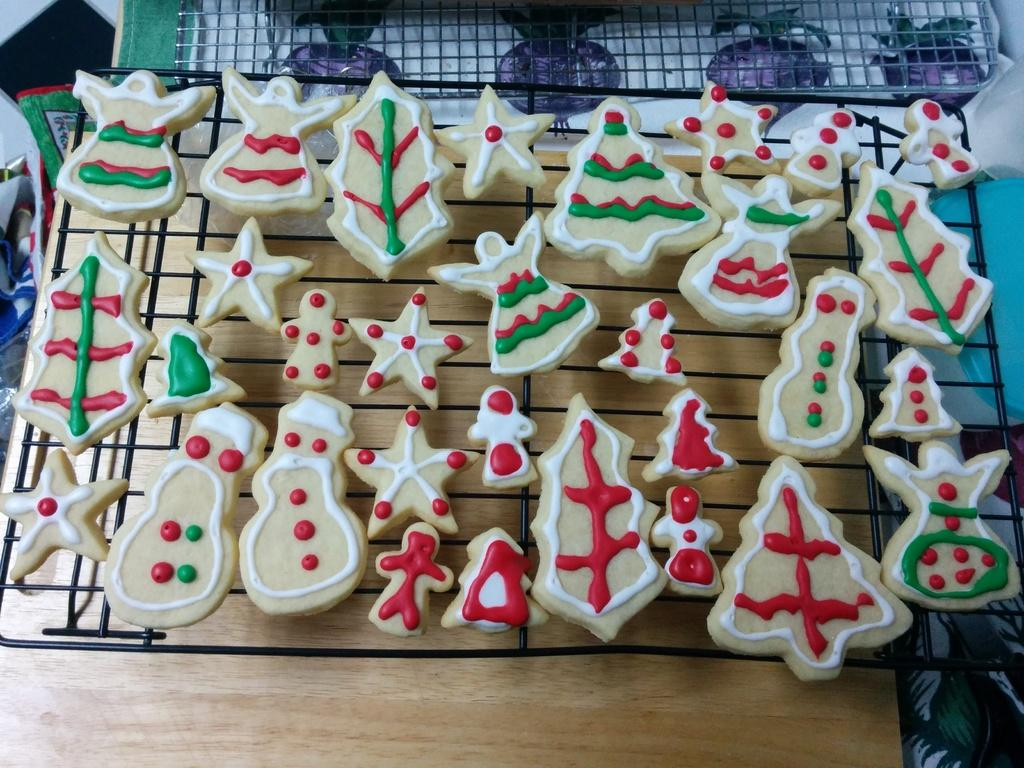What is being cooked on the grill in the image? There are food items on the grill in the image. Can you describe the colors of the food on the grill? The food has various colors, including brown, white, red, and green. What is the surface beneath the grill made of? The grill is on a brown surface. What other objects can be seen around the grill? There are objects visible around the grill. How many sisters are standing next to the grill in the image? There are no sisters present in the image. What is the value of the rake leaning against the grill in the image? There is no rake present in the image, so it is not possible to determine its value. 